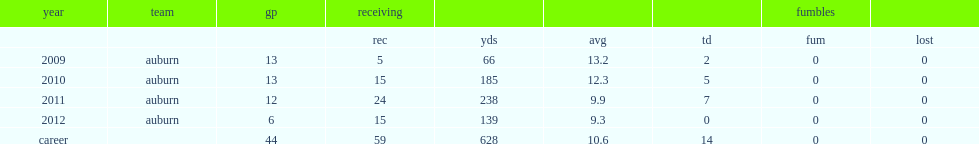How many receptions did philip lutzenkirchen end his career with? 59.0. How many yards did philip lutzenkirchen end his career with? 628.0. How many touchdowns did philip lutzenkirchen end his career with? 14.0. 